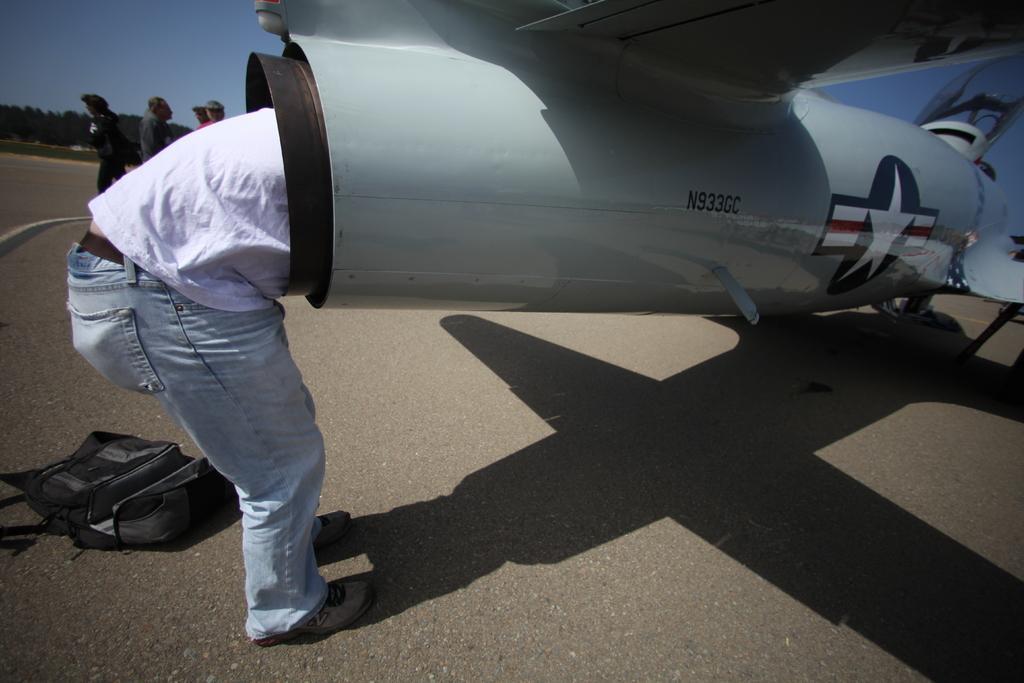Could you give a brief overview of what you see in this image? In this image there is a person placed his head in the part of an airplane, behind them there are a few people standing, there is a bag on the surface and in the background there is the sky. 